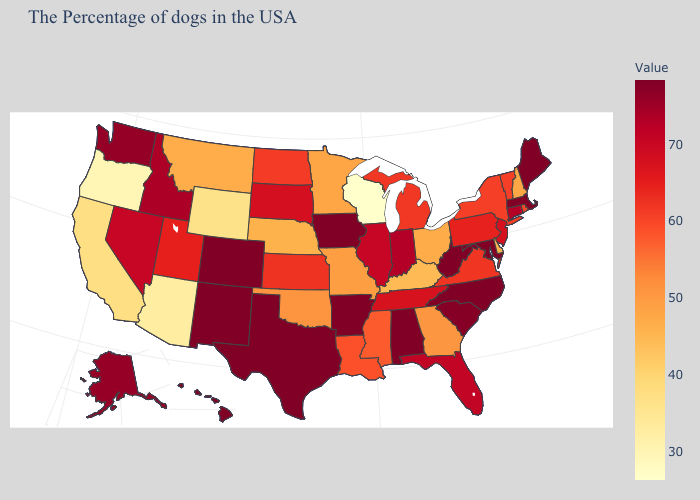Among the states that border Massachusetts , does New Hampshire have the lowest value?
Answer briefly. Yes. Does Iowa have the highest value in the MidWest?
Answer briefly. Yes. Among the states that border Florida , does Alabama have the highest value?
Keep it brief. Yes. Does South Carolina have a lower value than Wyoming?
Give a very brief answer. No. Among the states that border Indiana , does Michigan have the highest value?
Give a very brief answer. No. Which states have the lowest value in the South?
Short answer required. Kentucky. 